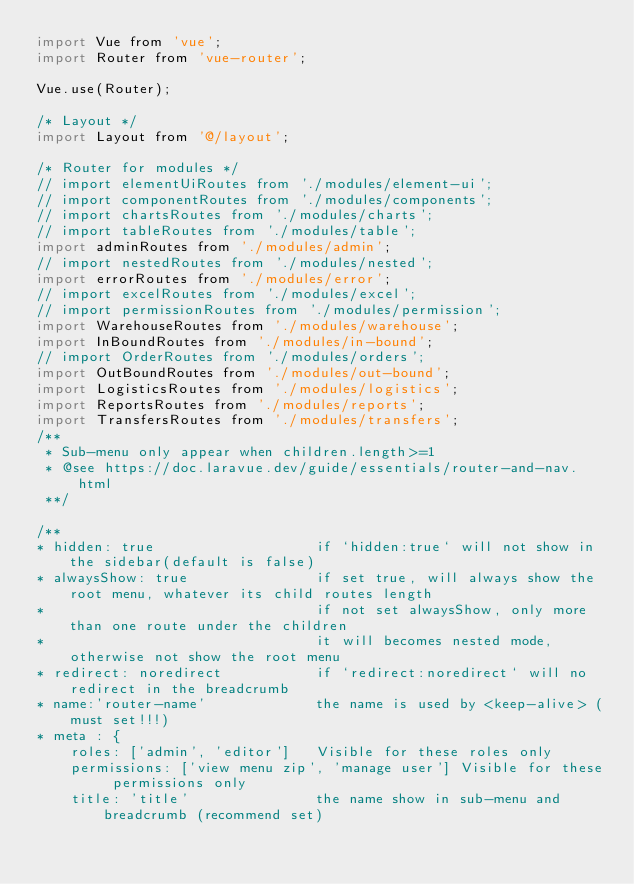<code> <loc_0><loc_0><loc_500><loc_500><_JavaScript_>import Vue from 'vue';
import Router from 'vue-router';

Vue.use(Router);

/* Layout */
import Layout from '@/layout';

/* Router for modules */
// import elementUiRoutes from './modules/element-ui';
// import componentRoutes from './modules/components';
// import chartsRoutes from './modules/charts';
// import tableRoutes from './modules/table';
import adminRoutes from './modules/admin';
// import nestedRoutes from './modules/nested';
import errorRoutes from './modules/error';
// import excelRoutes from './modules/excel';
// import permissionRoutes from './modules/permission';
import WarehouseRoutes from './modules/warehouse';
import InBoundRoutes from './modules/in-bound';
// import OrderRoutes from './modules/orders';
import OutBoundRoutes from './modules/out-bound';
import LogisticsRoutes from './modules/logistics';
import ReportsRoutes from './modules/reports';
import TransfersRoutes from './modules/transfers';
/**
 * Sub-menu only appear when children.length>=1
 * @see https://doc.laravue.dev/guide/essentials/router-and-nav.html
 **/

/**
* hidden: true                   if `hidden:true` will not show in the sidebar(default is false)
* alwaysShow: true               if set true, will always show the root menu, whatever its child routes length
*                                if not set alwaysShow, only more than one route under the children
*                                it will becomes nested mode, otherwise not show the root menu
* redirect: noredirect           if `redirect:noredirect` will no redirect in the breadcrumb
* name:'router-name'             the name is used by <keep-alive> (must set!!!)
* meta : {
    roles: ['admin', 'editor']   Visible for these roles only
    permissions: ['view menu zip', 'manage user'] Visible for these permissions only
    title: 'title'               the name show in sub-menu and breadcrumb (recommend set)</code> 